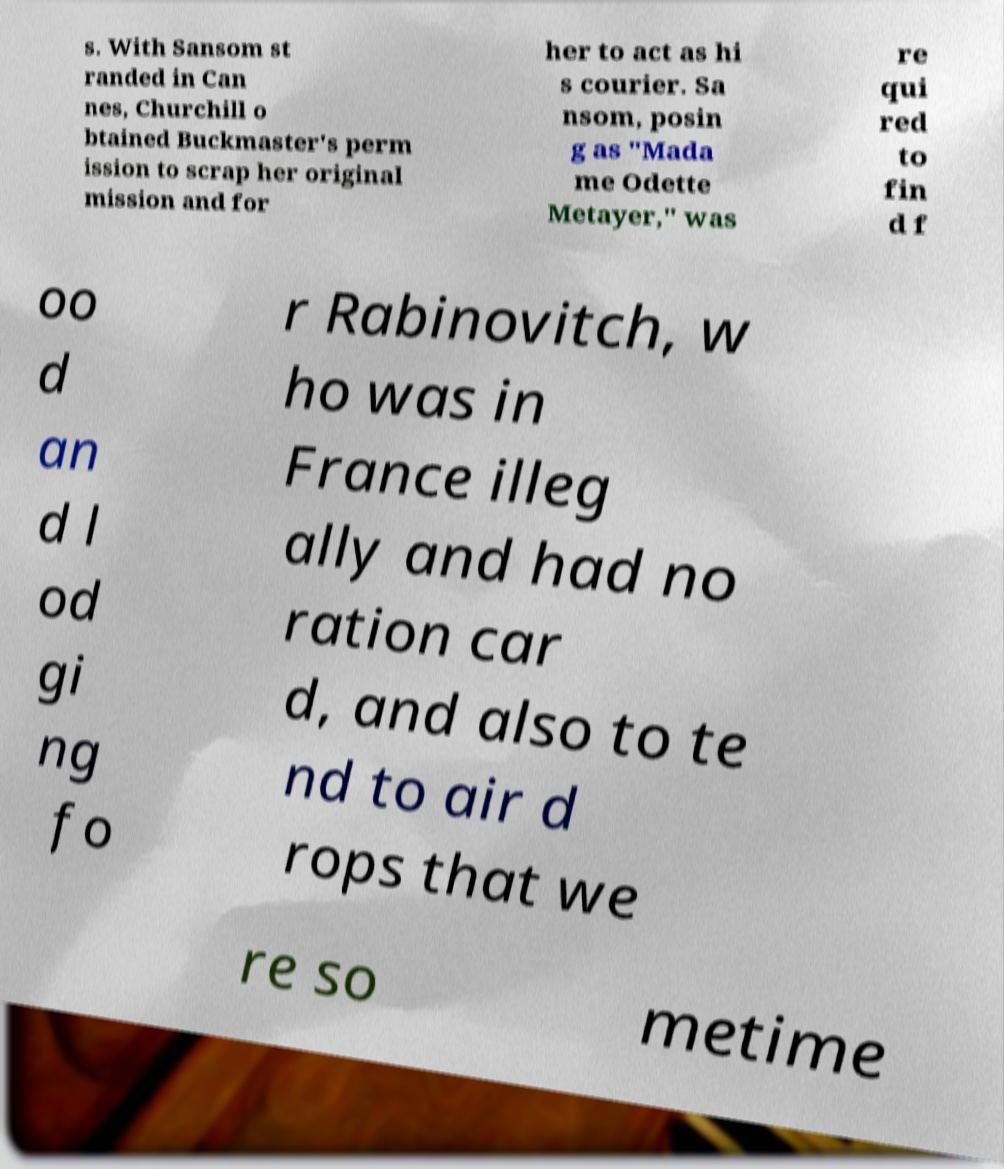Can you read and provide the text displayed in the image?This photo seems to have some interesting text. Can you extract and type it out for me? s. With Sansom st randed in Can nes, Churchill o btained Buckmaster's perm ission to scrap her original mission and for her to act as hi s courier. Sa nsom, posin g as "Mada me Odette Metayer," was re qui red to fin d f oo d an d l od gi ng fo r Rabinovitch, w ho was in France illeg ally and had no ration car d, and also to te nd to air d rops that we re so metime 